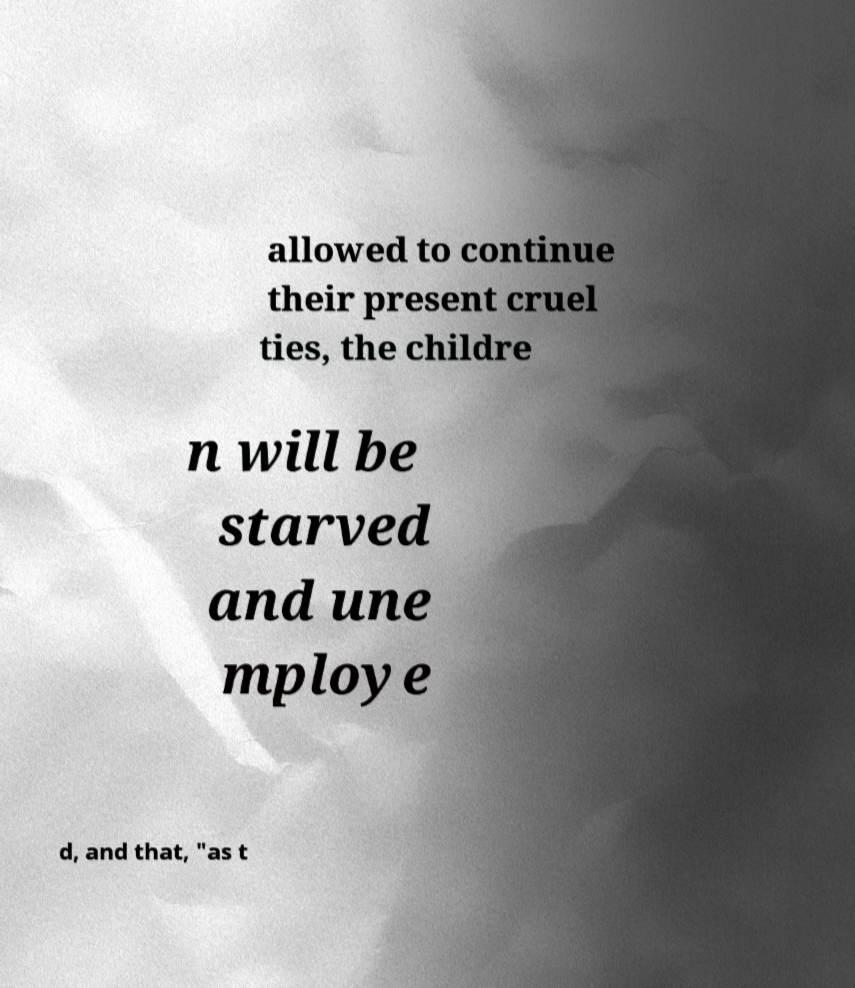Can you accurately transcribe the text from the provided image for me? allowed to continue their present cruel ties, the childre n will be starved and une mploye d, and that, "as t 